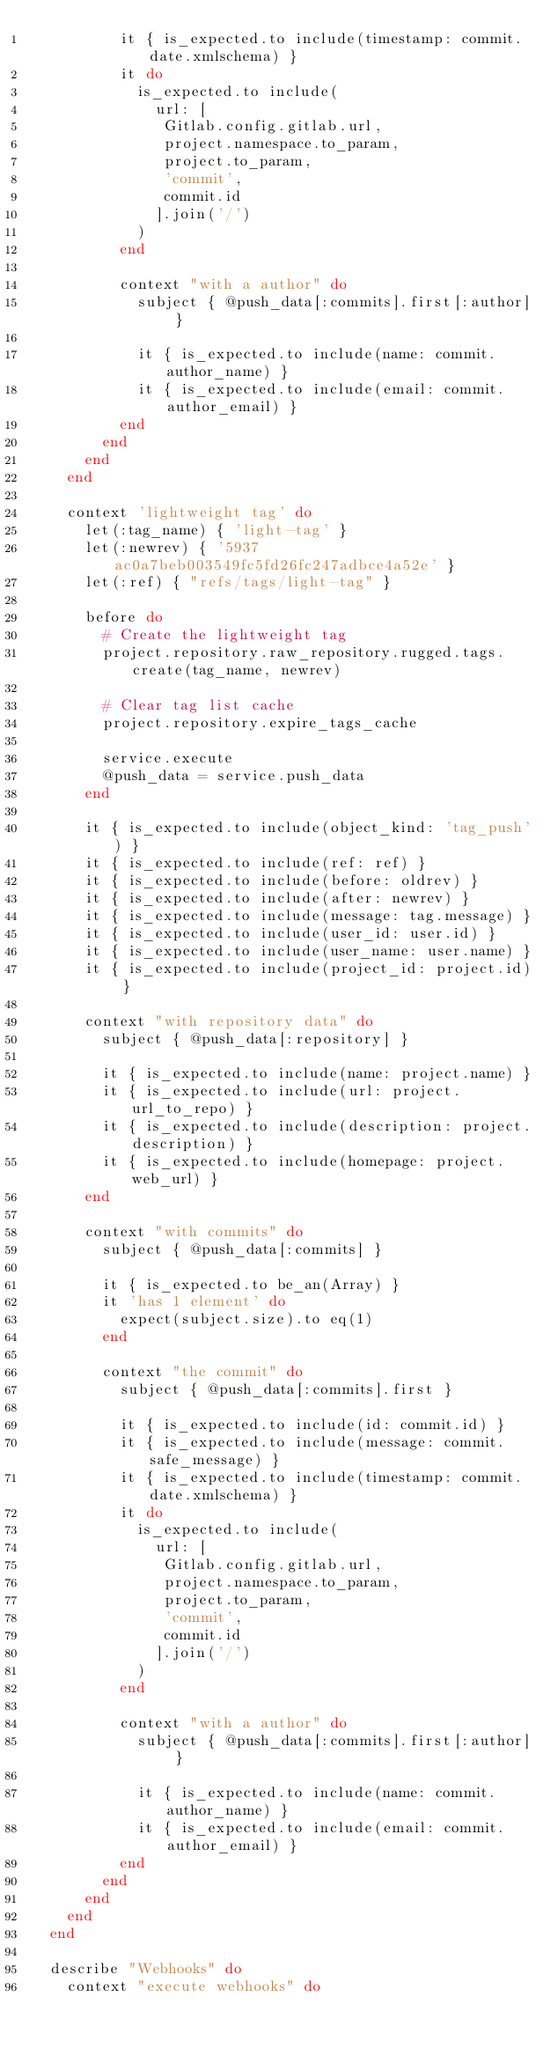Convert code to text. <code><loc_0><loc_0><loc_500><loc_500><_Ruby_>          it { is_expected.to include(timestamp: commit.date.xmlschema) }
          it do
            is_expected.to include(
              url: [
               Gitlab.config.gitlab.url,
               project.namespace.to_param,
               project.to_param,
               'commit',
               commit.id
              ].join('/')
            )
          end

          context "with a author" do
            subject { @push_data[:commits].first[:author] }

            it { is_expected.to include(name: commit.author_name) }
            it { is_expected.to include(email: commit.author_email) }
          end
        end
      end
    end

    context 'lightweight tag' do
      let(:tag_name) { 'light-tag' }
      let(:newrev) { '5937ac0a7beb003549fc5fd26fc247adbce4a52e' }
      let(:ref) { "refs/tags/light-tag" }

      before do
        # Create the lightweight tag
        project.repository.raw_repository.rugged.tags.create(tag_name, newrev)

        # Clear tag list cache
        project.repository.expire_tags_cache

        service.execute
        @push_data = service.push_data
      end

      it { is_expected.to include(object_kind: 'tag_push') }
      it { is_expected.to include(ref: ref) }
      it { is_expected.to include(before: oldrev) }
      it { is_expected.to include(after: newrev) }
      it { is_expected.to include(message: tag.message) }
      it { is_expected.to include(user_id: user.id) }
      it { is_expected.to include(user_name: user.name) }
      it { is_expected.to include(project_id: project.id) }

      context "with repository data" do
        subject { @push_data[:repository] }

        it { is_expected.to include(name: project.name) }
        it { is_expected.to include(url: project.url_to_repo) }
        it { is_expected.to include(description: project.description) }
        it { is_expected.to include(homepage: project.web_url) }
      end

      context "with commits" do
        subject { @push_data[:commits] }

        it { is_expected.to be_an(Array) }
        it 'has 1 element' do
          expect(subject.size).to eq(1)
        end

        context "the commit" do
          subject { @push_data[:commits].first }

          it { is_expected.to include(id: commit.id) }
          it { is_expected.to include(message: commit.safe_message) }
          it { is_expected.to include(timestamp: commit.date.xmlschema) }
          it do
            is_expected.to include(
              url: [
               Gitlab.config.gitlab.url,
               project.namespace.to_param,
               project.to_param,
               'commit',
               commit.id
              ].join('/')
            )
          end

          context "with a author" do
            subject { @push_data[:commits].first[:author] }

            it { is_expected.to include(name: commit.author_name) }
            it { is_expected.to include(email: commit.author_email) }
          end
        end
      end
    end
  end

  describe "Webhooks" do
    context "execute webhooks" do</code> 